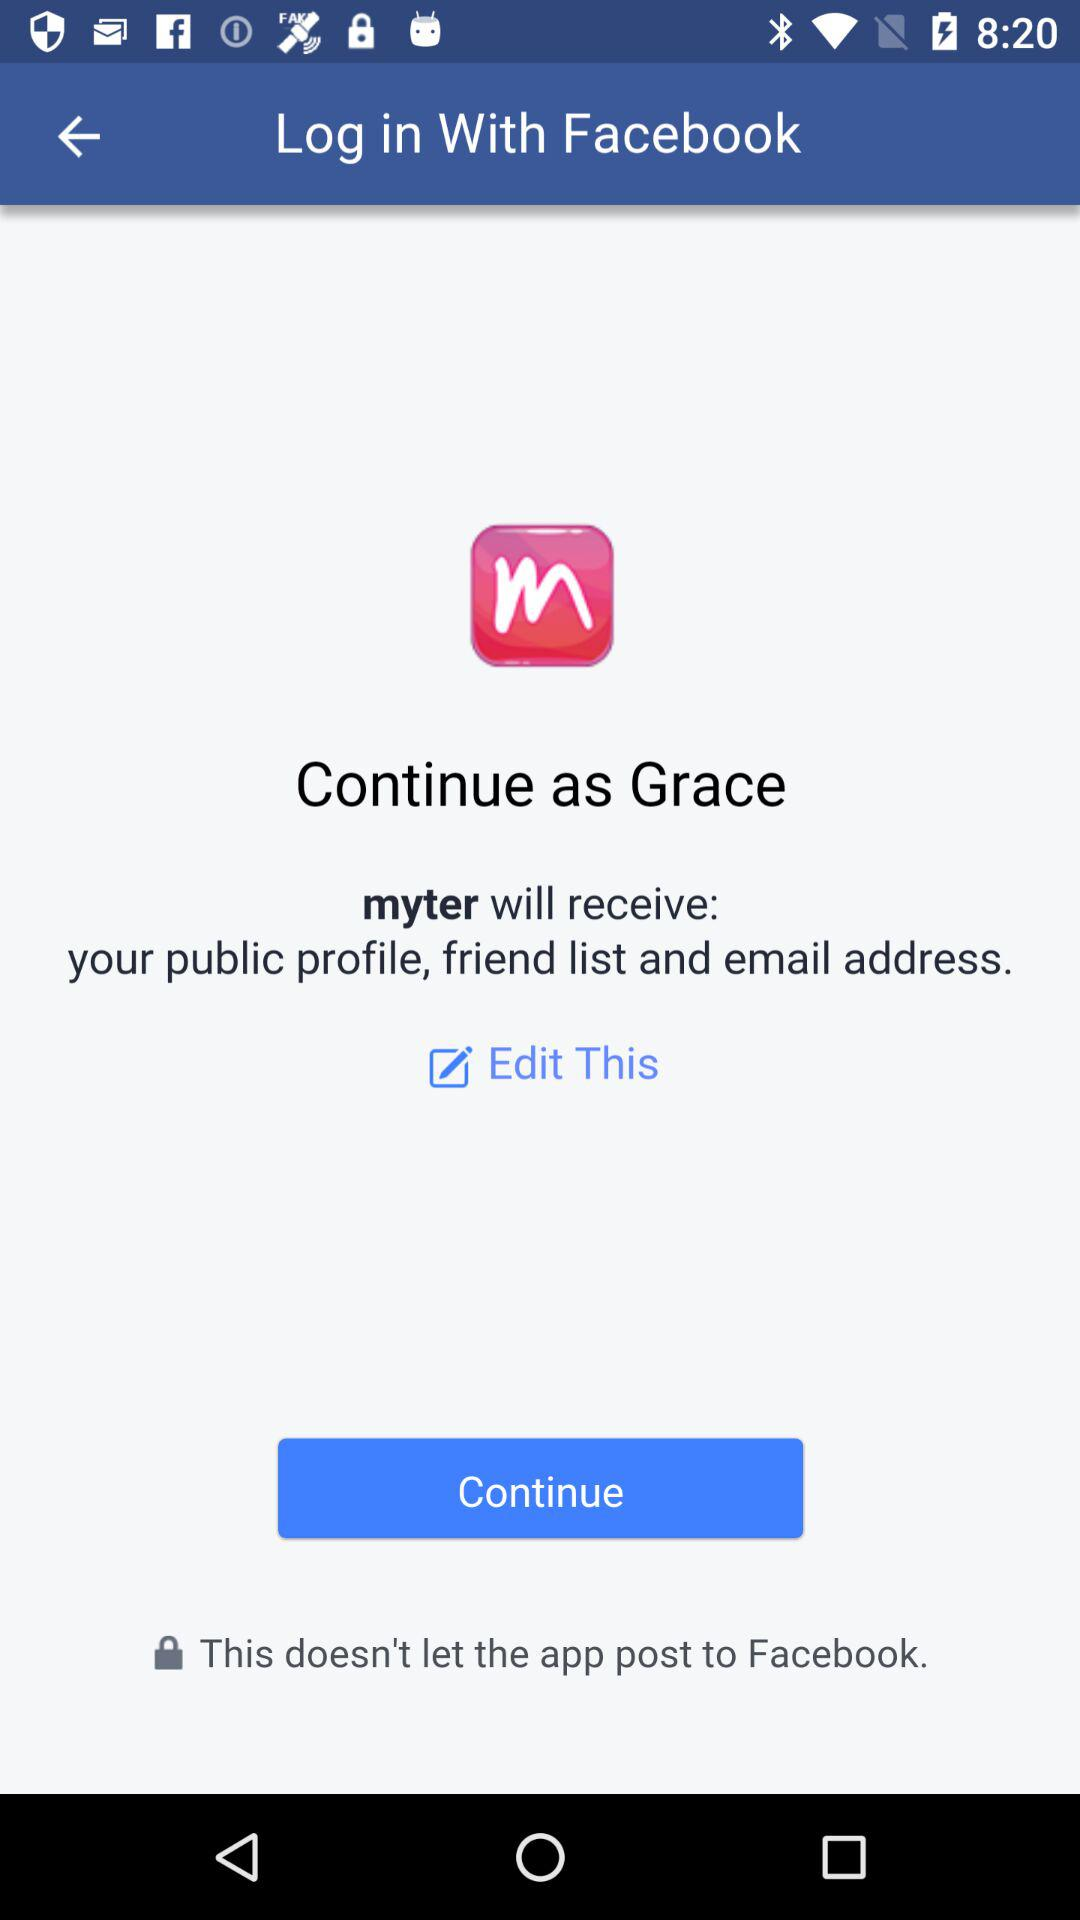What application is asking for permission? The application that is asking for permission is "myter". 